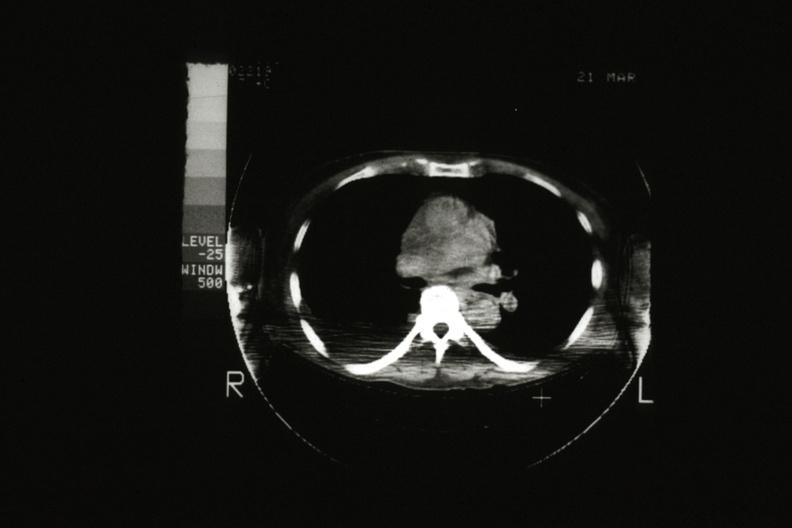what does this image show?
Answer the question using a single word or phrase. Cat scan showing tumor mass invading superior vena ca 